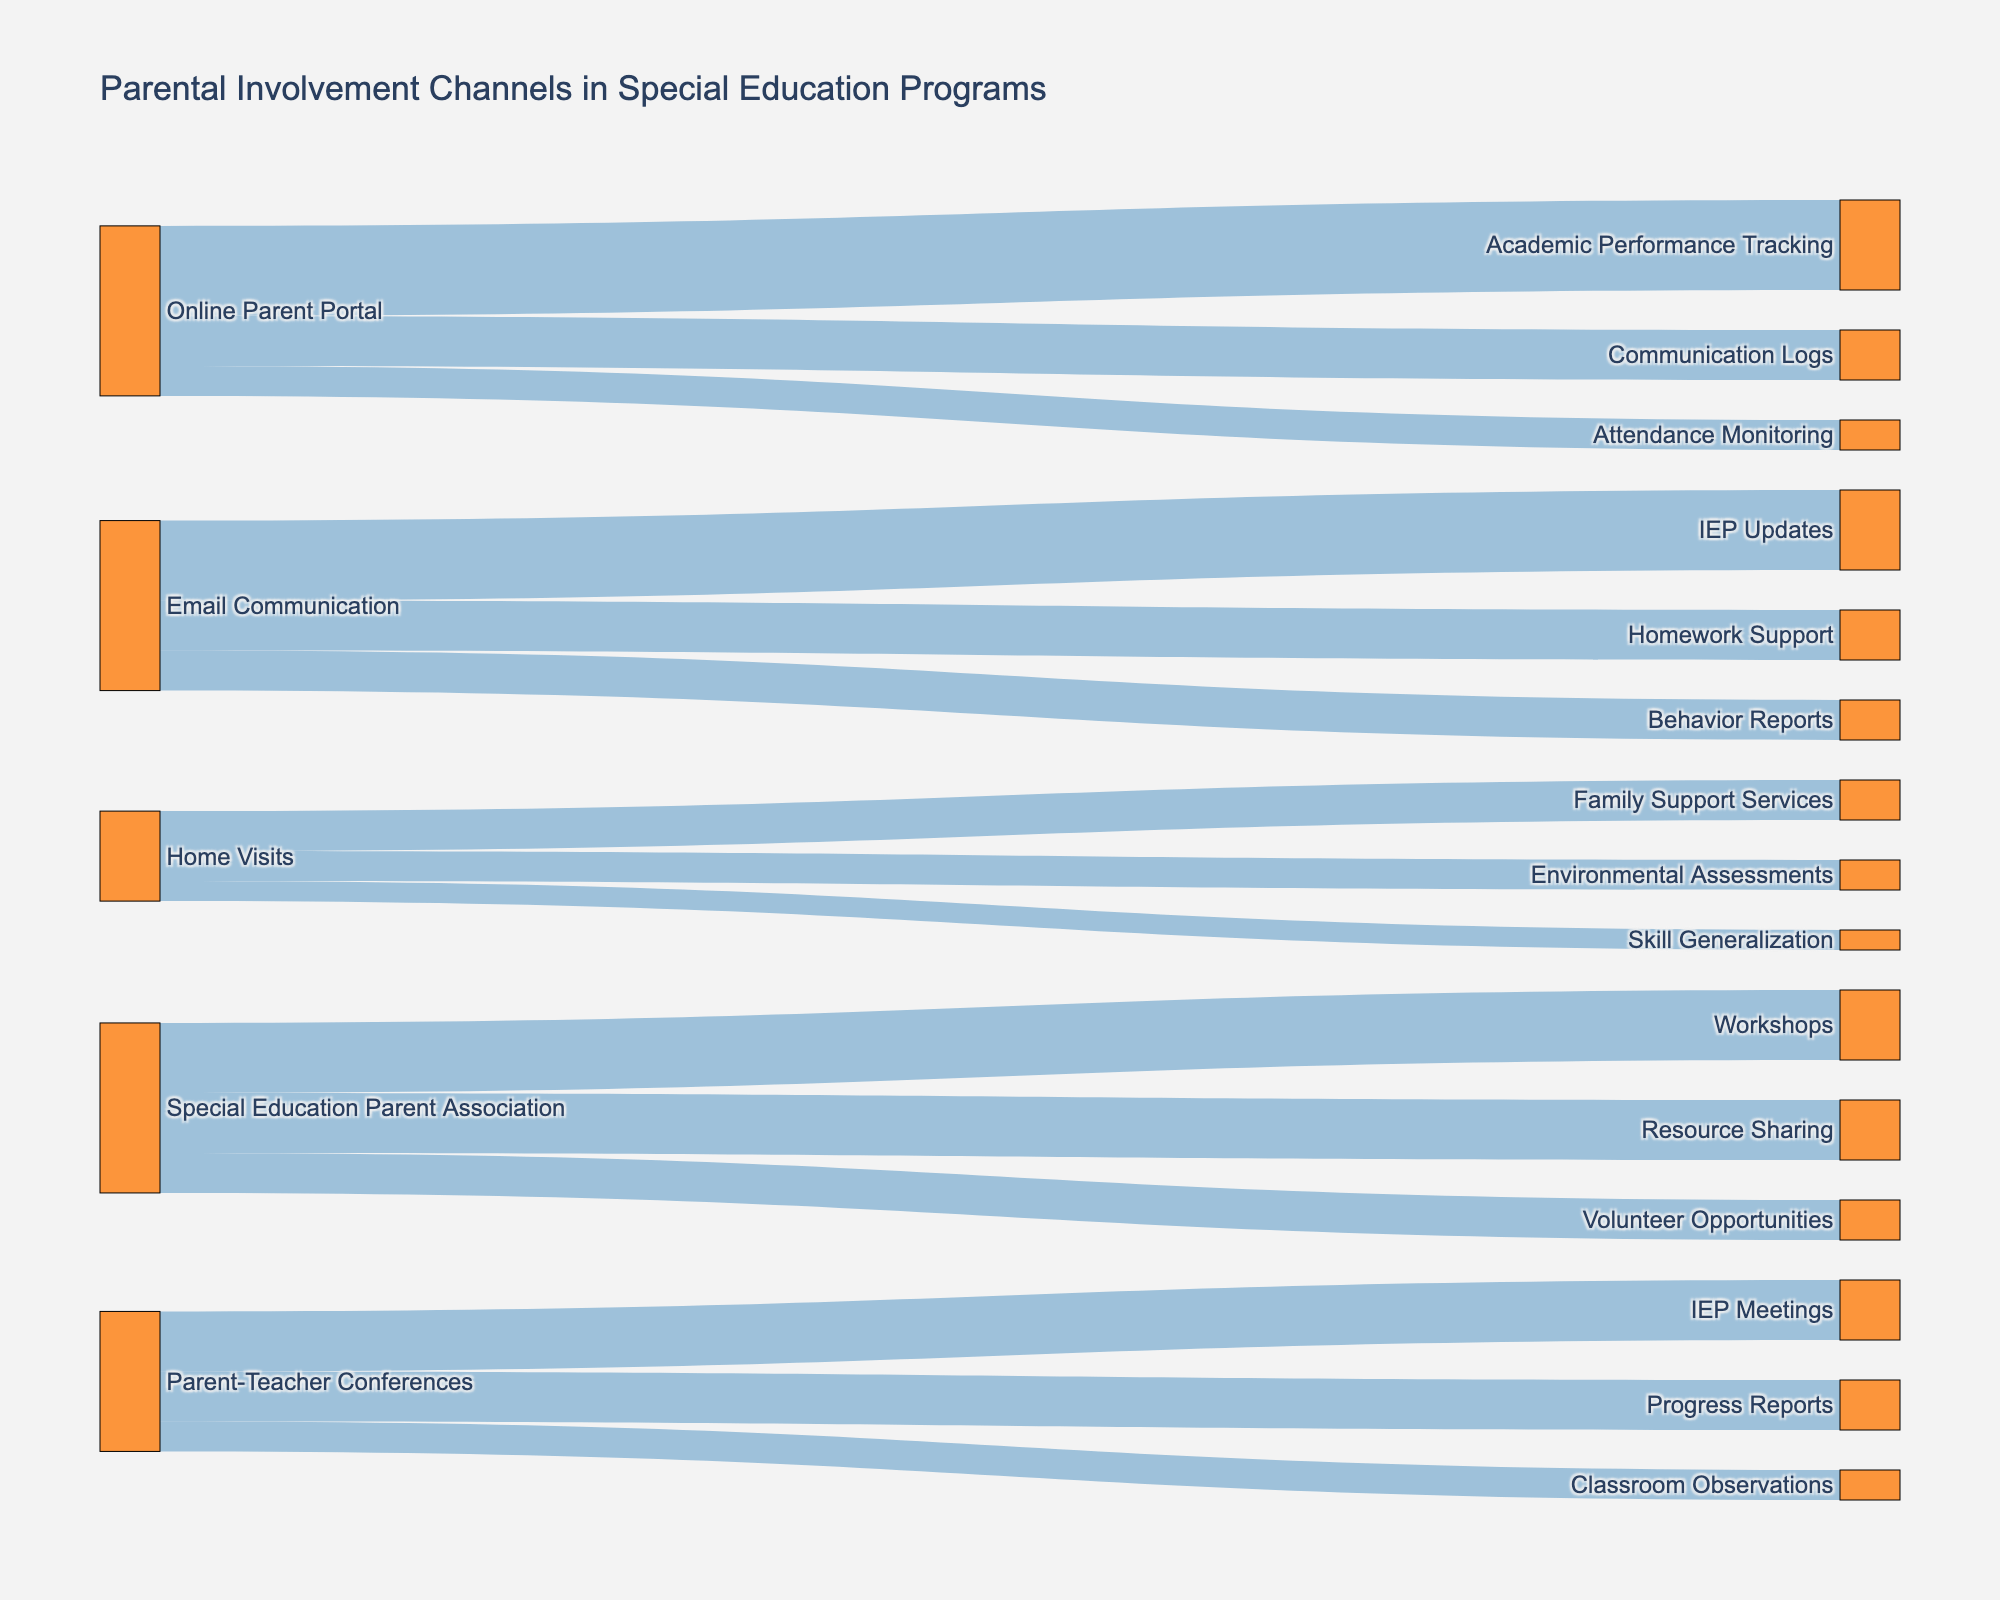Which parental involvement channel has the highest value? The parental involvement channel with the highest value can be identified by looking at the source with the largest number represented in the diagram. "Online Parent Portal" with "Academic Performance Tracking" has the highest value of 45.
Answer: Online Parent Portal with Academic Performance Tracking How many total channels are associated with Email Communication? To find the total number of channels associated with Email Communication, count the links originating from the Email Communication source: IEP Updates (40), Behavior Reports (20), and Homework Support (25).
Answer: 3 Which involvement channel(s) have the smallest value? By checking the values for each link, the smallest value is found to be for "Skill Generalization" associated with "Home Visits" with a value of 10.
Answer: Skill Generalization with Home Visits What is the combined value for the channels associated with Special Education Parent Association? Add up the values associated with "Special Education Parent Association": Workshops (35), Volunteer Opportunities (20), and Resource Sharing (30). Therefore, 35 + 20 + 30 = 85.
Answer: 85 Compare the total values of the channels associated with Home Visits and Parent-Teacher Conferences. Which has a higher total? Add up the values for each source individually. Home Visits: Family Support Services (20), Environmental Assessments (15), and Skill Generalization (10) sum to 45. Parent-Teacher Conferences: IEP Meetings (30), Progress Reports (25), and Classroom Observations (15) sum to 70. So, Parent-Teacher Conferences has a higher total value.
Answer: Parent-Teacher Conferences What is the title of the figure? The title of the figure is displayed at the top, which describes what the chart represents.
Answer: Parental Involvement Channels in Special Education Programs What color represents the links in the diagram? The links in the diagram are represented in blue with some level of transparency (appearing as light blue).
Answer: Blue Which channels are associated with Classroom Observations, and what is their total value? There is only one target associated with Classroom Observations, which is Parent-Teacher Conferences with a value of 15.
Answer: 15 What is the difference between the values of Workshops and Volunteer Opportunities in the Special Education Parent Association channels? Workshops have a value of 35, and Volunteer Opportunities have a value of 20. The difference is 35 - 20 = 15.
Answer: 15 Identify which source node has the largest number of target nodes. Look at the number of links originating from each source. "Online Parent Portal" and "Email Communication" both have three target nodes each, the maximum number displayed.
Answer: Online Parent Portal and Email Communication 